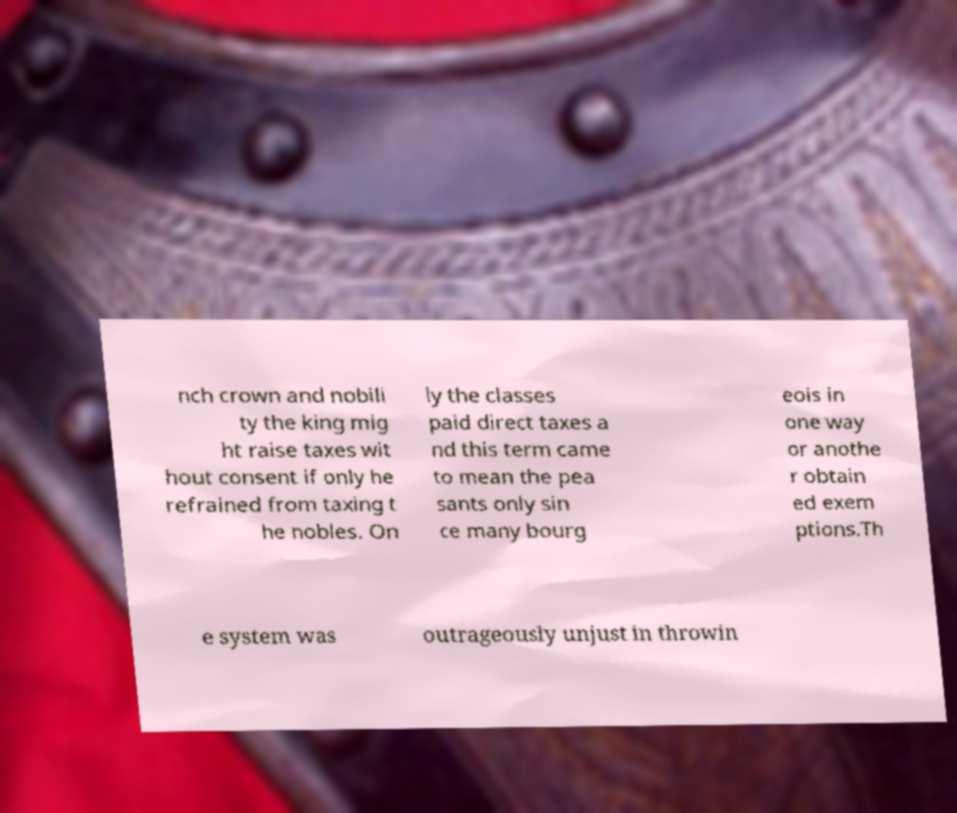Please identify and transcribe the text found in this image. nch crown and nobili ty the king mig ht raise taxes wit hout consent if only he refrained from taxing t he nobles. On ly the classes paid direct taxes a nd this term came to mean the pea sants only sin ce many bourg eois in one way or anothe r obtain ed exem ptions.Th e system was outrageously unjust in throwin 